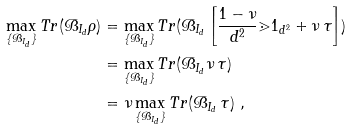<formula> <loc_0><loc_0><loc_500><loc_500>\max _ { \{ \mathcal { B } _ { I _ { d } } \} } T r ( \mathcal { B } _ { I _ { d } } \rho ) & = \max _ { \{ \mathcal { B } _ { I _ { d } } \} } T r ( \mathcal { B } _ { I _ { d } } \left [ \frac { 1 - \nu } { d ^ { 2 } } \mathbb { m } { 1 } _ { d ^ { 2 } } + \nu \, \tau \right ] ) \\ & = \max _ { \{ \mathcal { B } _ { I _ { d } } \} } T r ( \mathcal { B } _ { I _ { d } } \nu \, \tau ) \\ & = \nu \max _ { \{ \mathcal { B } _ { I _ { d } } \} } T r ( \mathcal { B } _ { I _ { d } } \, \tau ) \ ,</formula> 